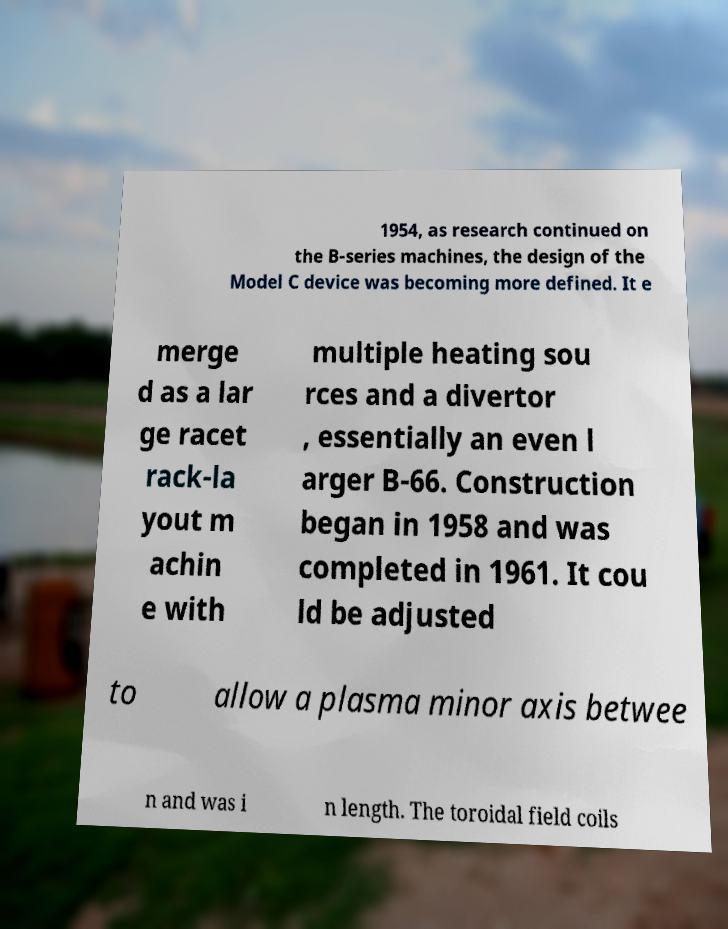For documentation purposes, I need the text within this image transcribed. Could you provide that? 1954, as research continued on the B-series machines, the design of the Model C device was becoming more defined. It e merge d as a lar ge racet rack-la yout m achin e with multiple heating sou rces and a divertor , essentially an even l arger B-66. Construction began in 1958 and was completed in 1961. It cou ld be adjusted to allow a plasma minor axis betwee n and was i n length. The toroidal field coils 